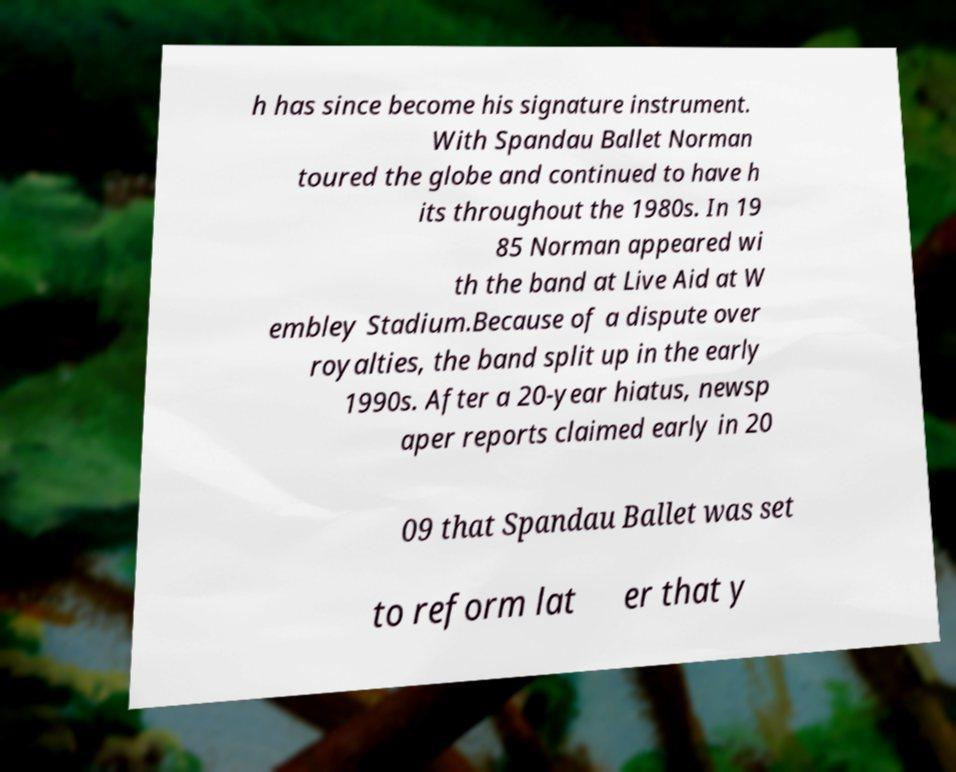Could you extract and type out the text from this image? h has since become his signature instrument. With Spandau Ballet Norman toured the globe and continued to have h its throughout the 1980s. In 19 85 Norman appeared wi th the band at Live Aid at W embley Stadium.Because of a dispute over royalties, the band split up in the early 1990s. After a 20-year hiatus, newsp aper reports claimed early in 20 09 that Spandau Ballet was set to reform lat er that y 